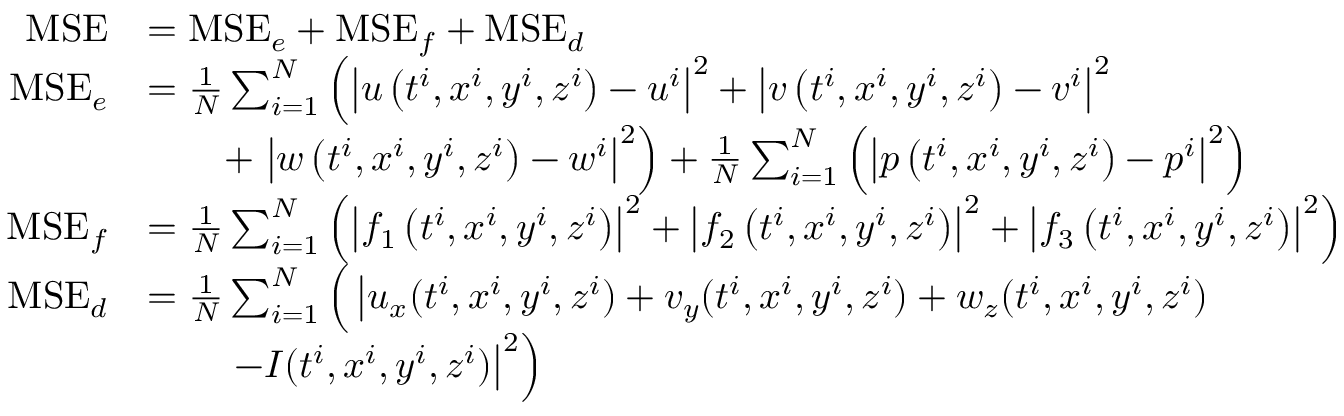Convert formula to latex. <formula><loc_0><loc_0><loc_500><loc_500>\begin{array} { r l } { M S E } & { = M S E _ { e } + M S E _ { f } + M S E _ { d } } \\ { M S E _ { e } } & { = \frac { 1 } { N } \sum _ { i = 1 } ^ { N } \left ( \left | u \left ( t ^ { i } , x ^ { i } , y ^ { i } , z ^ { i } \right ) - u ^ { i } \right | ^ { 2 } + \left | v \left ( t ^ { i } , x ^ { i } , y ^ { i } , z ^ { i } \right ) - v ^ { i } \right | ^ { 2 } } \\ & { \quad + \left | w \left ( t ^ { i } , x ^ { i } , y ^ { i } , z ^ { i } \right ) - w ^ { i } \right | ^ { 2 } \right ) + \frac { 1 } { N } \sum _ { i = 1 } ^ { N } \left ( \left | p \left ( t ^ { i } , x ^ { i } , y ^ { i } , z ^ { i } \right ) - p ^ { i } \right | ^ { 2 } \right ) } \\ { M S E _ { f } } & { = \frac { 1 } { N } \sum _ { i = 1 } ^ { N } \left ( \left | f _ { 1 } \left ( t ^ { i } , x ^ { i } , y ^ { i } , z ^ { i } \right ) \right | ^ { 2 } + \left | f _ { 2 } \left ( t ^ { i } , x ^ { i } , y ^ { i } , z ^ { i } \right ) \right | ^ { 2 } + \left | f _ { 3 } \left ( t ^ { i } , x ^ { i } , y ^ { i } , z ^ { i } \right ) \right | ^ { 2 } \right ) } \\ { M S E _ { d } } & { = \frac { 1 } { N } \sum _ { i = 1 } ^ { N } \Big ( \left | u _ { x } ( t ^ { i } , x ^ { i } , y ^ { i } , z ^ { i } ) + v _ { y } ( t ^ { i } , x ^ { i } , y ^ { i } , z ^ { i } ) + w _ { z } ( t ^ { i } , x ^ { i } , y ^ { i } , z ^ { i } ) \Big . } \\ & { \quad - I ( t ^ { i } , x ^ { i } , y ^ { i } , z ^ { i } ) \right | ^ { 2 } \right ) } \end{array}</formula> 